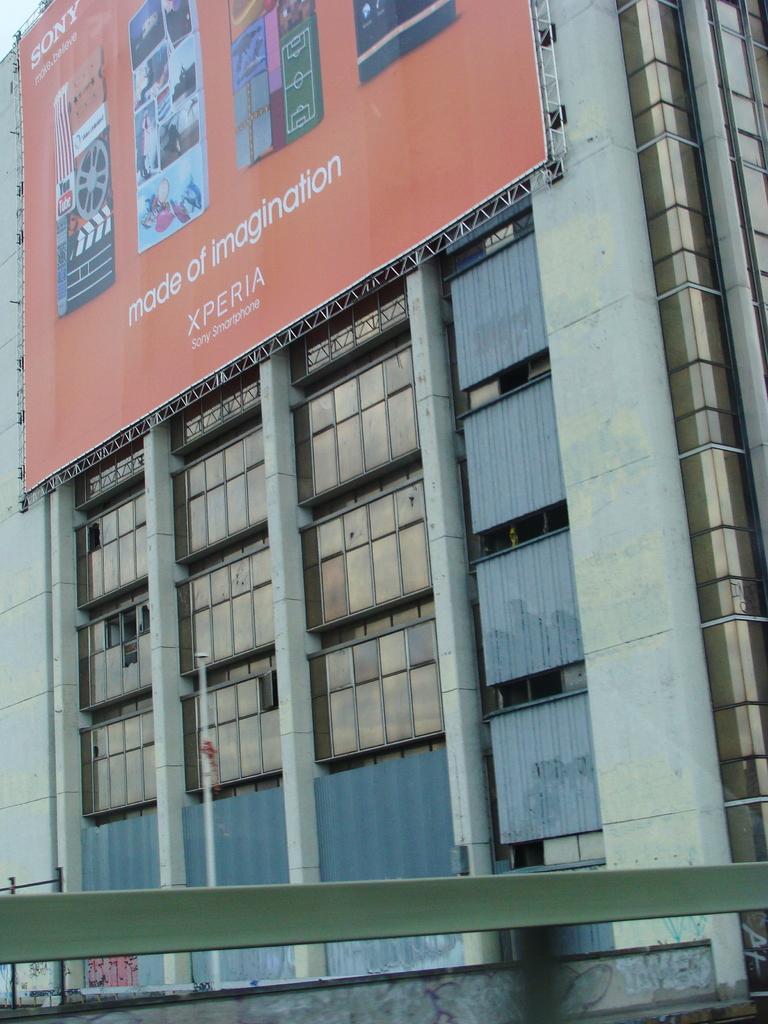Describe this image in one or two sentences. In this image we can see there is a big poster about xperia Sony smartphones. 